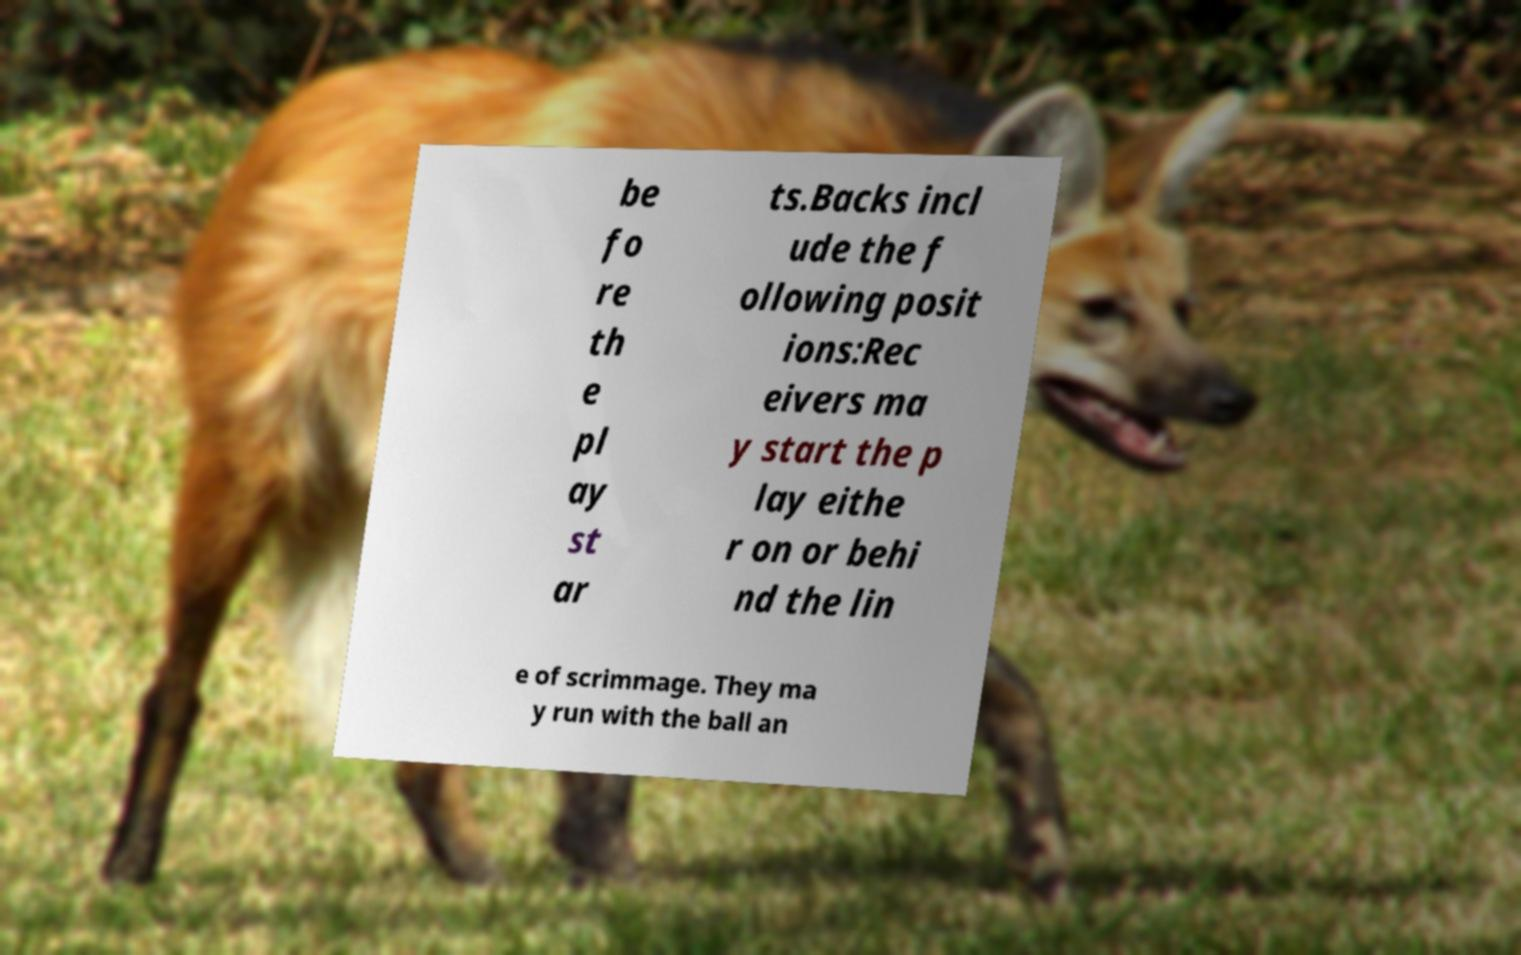I need the written content from this picture converted into text. Can you do that? be fo re th e pl ay st ar ts.Backs incl ude the f ollowing posit ions:Rec eivers ma y start the p lay eithe r on or behi nd the lin e of scrimmage. They ma y run with the ball an 